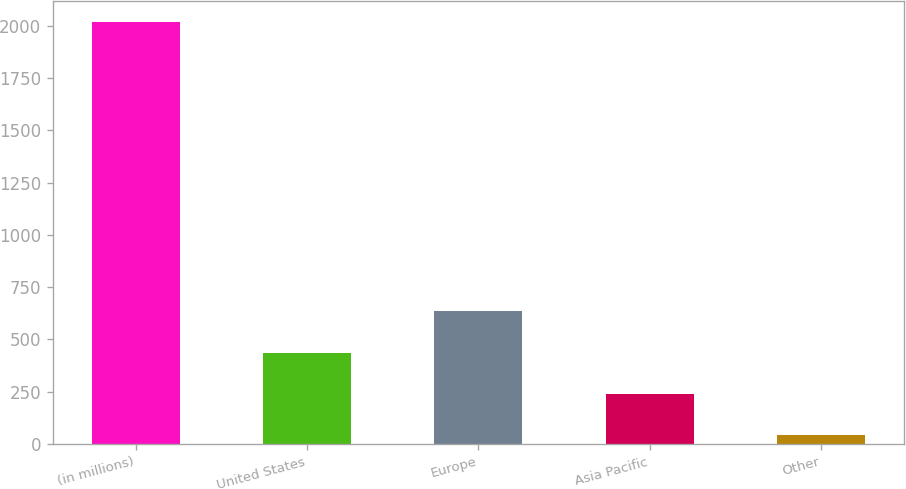Convert chart to OTSL. <chart><loc_0><loc_0><loc_500><loc_500><bar_chart><fcel>(in millions)<fcel>United States<fcel>Europe<fcel>Asia Pacific<fcel>Other<nl><fcel>2017<fcel>436.2<fcel>633.8<fcel>238.6<fcel>41<nl></chart> 